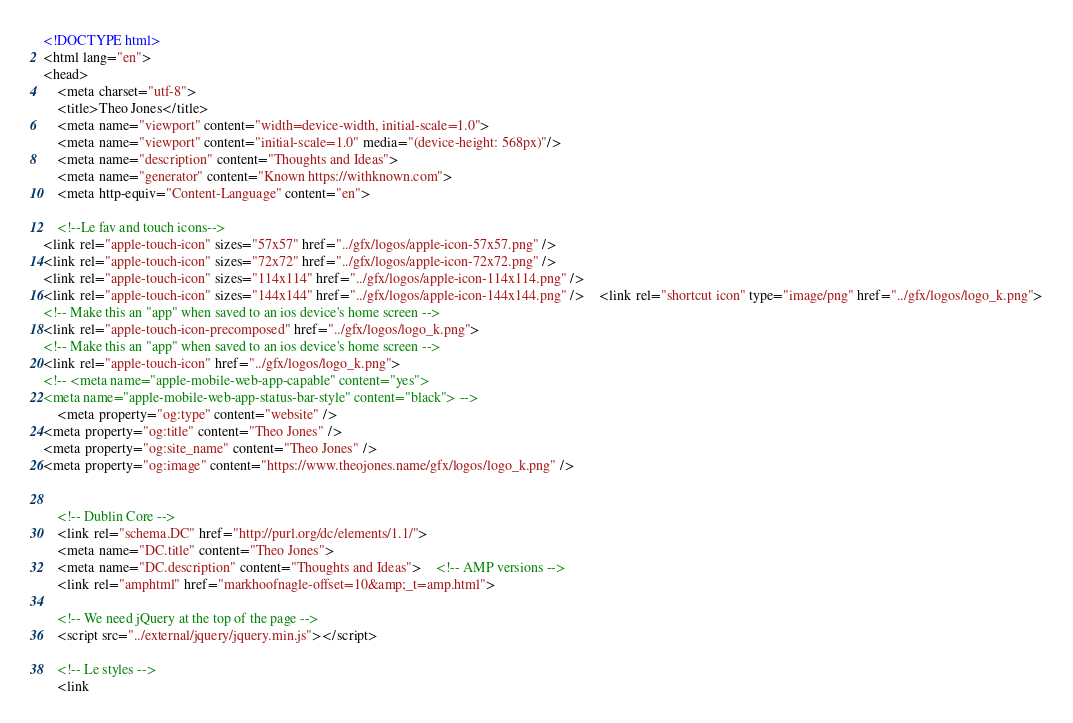Convert code to text. <code><loc_0><loc_0><loc_500><loc_500><_HTML_><!DOCTYPE html>
<html lang="en">
<head>
    <meta charset="utf-8">
    <title>Theo Jones</title>
    <meta name="viewport" content="width=device-width, initial-scale=1.0">
    <meta name="viewport" content="initial-scale=1.0" media="(device-height: 568px)"/>
    <meta name="description" content="Thoughts and Ideas">
    <meta name="generator" content="Known https://withknown.com">
    <meta http-equiv="Content-Language" content="en">

    <!--Le fav and touch icons-->
<link rel="apple-touch-icon" sizes="57x57" href="../gfx/logos/apple-icon-57x57.png" />
<link rel="apple-touch-icon" sizes="72x72" href="../gfx/logos/apple-icon-72x72.png" />
<link rel="apple-touch-icon" sizes="114x114" href="../gfx/logos/apple-icon-114x114.png" />
<link rel="apple-touch-icon" sizes="144x144" href="../gfx/logos/apple-icon-144x144.png" />    <link rel="shortcut icon" type="image/png" href="../gfx/logos/logo_k.png">
<!-- Make this an "app" when saved to an ios device's home screen -->
<link rel="apple-touch-icon-precomposed" href="../gfx/logos/logo_k.png">
<!-- Make this an "app" when saved to an ios device's home screen -->
<link rel="apple-touch-icon" href="../gfx/logos/logo_k.png">
<!-- <meta name="apple-mobile-web-app-capable" content="yes">
<meta name="apple-mobile-web-app-status-bar-style" content="black"> -->
    <meta property="og:type" content="website" />
<meta property="og:title" content="Theo Jones" />
<meta property="og:site_name" content="Theo Jones" />
<meta property="og:image" content="https://www.theojones.name/gfx/logos/logo_k.png" />


    <!-- Dublin Core -->
    <link rel="schema.DC" href="http://purl.org/dc/elements/1.1/">
    <meta name="DC.title" content="Theo Jones">
    <meta name="DC.description" content="Thoughts and Ideas">    <!-- AMP versions -->
    <link rel="amphtml" href="markhoofnagle-offset=10&amp;_t=amp.html">

    <!-- We need jQuery at the top of the page -->
    <script src="../external/jquery/jquery.min.js"></script>

    <!-- Le styles -->
    <link</code> 